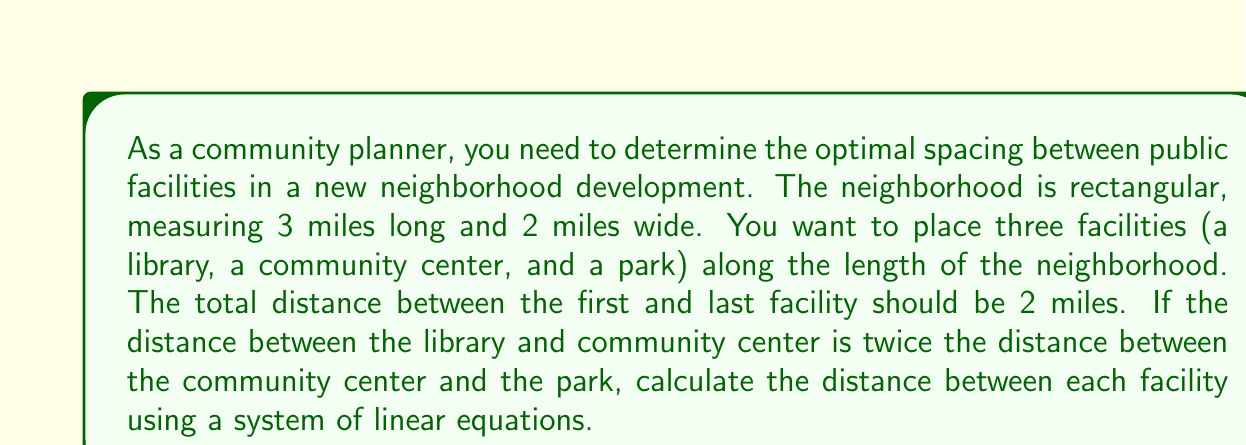Help me with this question. Let's approach this step-by-step:

1) Let's define our variables:
   $x$ = distance between library and community center
   $y$ = distance between community center and park

2) We can set up two equations based on the given information:

   Equation 1: The total distance between the first and last facility is 2 miles
   $$x + y = 2$$

   Equation 2: The distance between the library and community center is twice the distance between the community center and park
   $$x = 2y$$

3) We now have a system of linear equations:
   $$\begin{cases}
   x + y = 2 \\
   x = 2y
   \end{cases}$$

4) We can solve this system by substitution. Let's substitute the second equation into the first:
   $$(2y) + y = 2$$

5) Simplify:
   $$3y = 2$$

6) Solve for y:
   $$y = \frac{2}{3}$$

7) Now we can find x by substituting y back into either of our original equations. Let's use the second equation:
   $$x = 2y = 2(\frac{2}{3}) = \frac{4}{3}$$

8) Therefore, the distance between the library and community center (x) is $\frac{4}{3}$ miles, and the distance between the community center and park (y) is $\frac{2}{3}$ miles.
Answer: Library to Community Center: $\frac{4}{3}$ miles; Community Center to Park: $\frac{2}{3}$ miles 